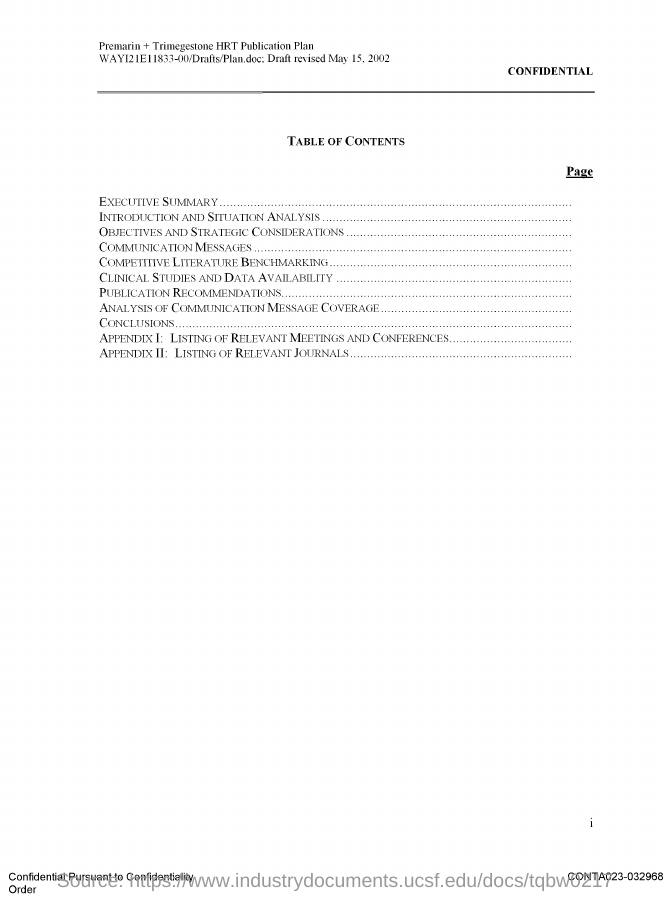Mention a couple of crucial points in this snapshot. What is the Page Number? I don't know. 